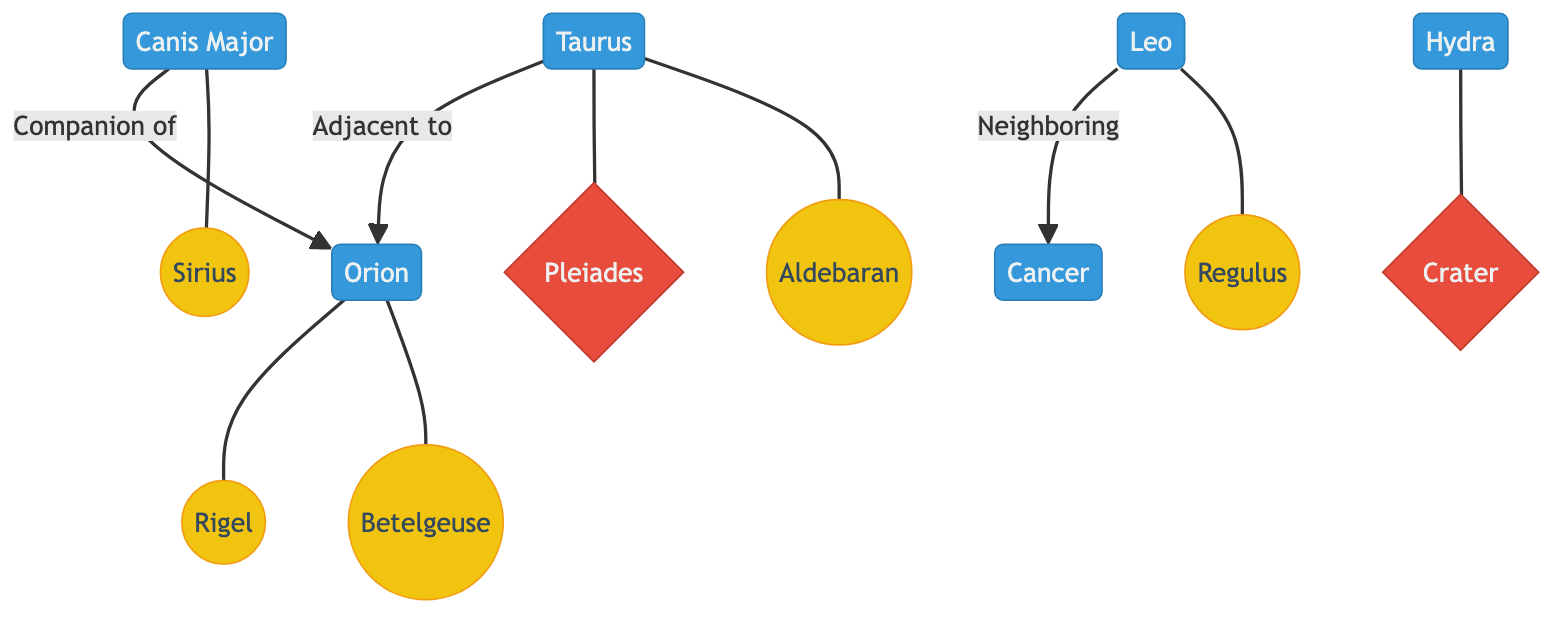What is the star associated with Orion? The star Betelgeuse is specifically connected to Orion in the diagram. It is outlined as being one of the stars linked to the constellation.
Answer: Betelgeuse How many major constellations are depicted in the diagram? By counting the distinct labels, there are a total of six major constellations visible in the diagram: Orion, Canis Major, Taurus, Hydra, Cancer, and Leo.
Answer: 6 Which constellation is adjacent to Taurus? The diagram shows that Taurus is adjacent to Orion as indicated by the arrow connecting those two constellations.
Answer: Orion What is Sirius? Sirius is labeled as the star associated with the constellation Canis Major in the diagram, making it a noteworthy celestial body within that context.
Answer: Star Which constellation is a neighbor to Leo? According to the diagram, Leo has an adjacent relationship with Cancer, demonstrated by the arrow pointing from Leo to Cancer.
Answer: Cancer What cluster is connected to Taurus? The diagram illustrates that Taurus has a connection to the Pleiades cluster, as indicated by the line drawn between them.
Answer: Pleiades Name the star associated with Leo. Regulus is shown as the star that is tied to the constellation Leo, as per the connections indicated in the diagram.
Answer: Regulus How many stars are directly connected to Orion? The diagram shows two stars connected to Orion: Betelgeuse and Rigel, making it easy to count and establish the quantity.
Answer: 2 Which constellation has a direct connection to the cluster Crater? The relationship depicted in the diagram shows that the constellation Hydra is linked directly to the cluster Crater.
Answer: Hydra 